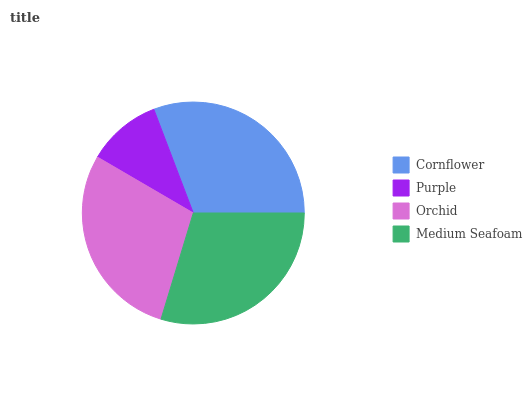Is Purple the minimum?
Answer yes or no. Yes. Is Cornflower the maximum?
Answer yes or no. Yes. Is Orchid the minimum?
Answer yes or no. No. Is Orchid the maximum?
Answer yes or no. No. Is Orchid greater than Purple?
Answer yes or no. Yes. Is Purple less than Orchid?
Answer yes or no. Yes. Is Purple greater than Orchid?
Answer yes or no. No. Is Orchid less than Purple?
Answer yes or no. No. Is Medium Seafoam the high median?
Answer yes or no. Yes. Is Orchid the low median?
Answer yes or no. Yes. Is Purple the high median?
Answer yes or no. No. Is Purple the low median?
Answer yes or no. No. 